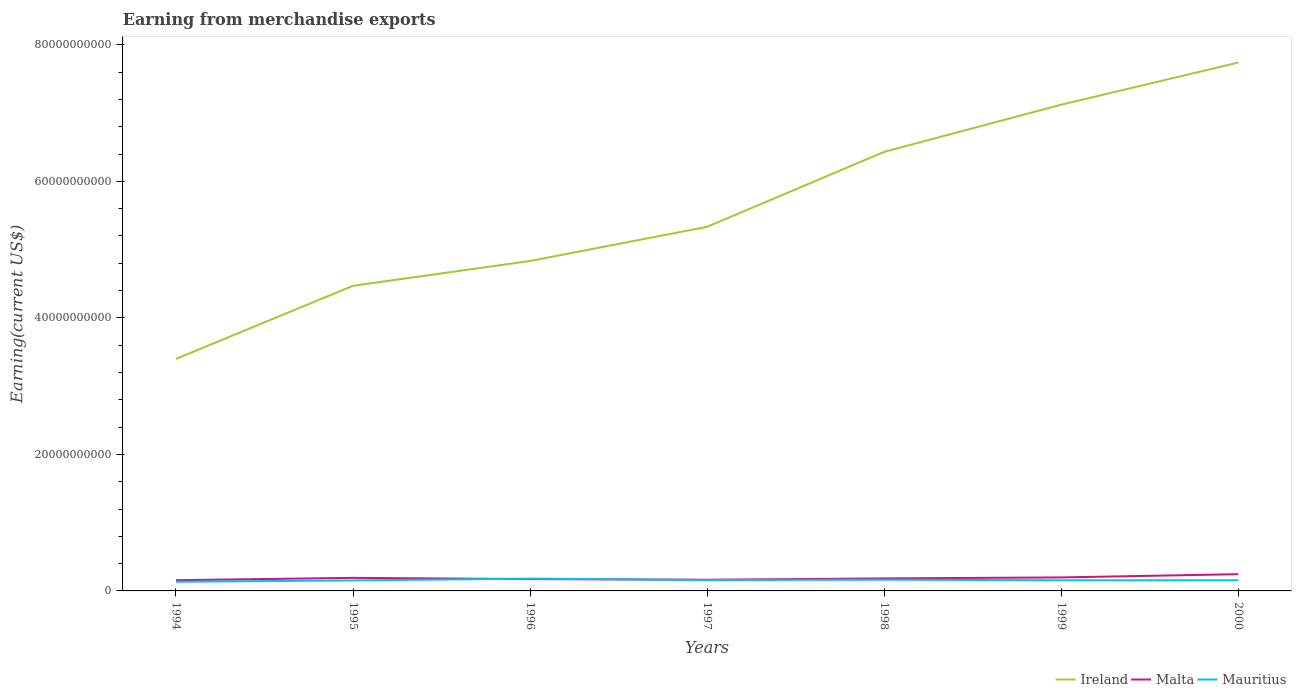How many different coloured lines are there?
Give a very brief answer. 3. Is the number of lines equal to the number of legend labels?
Keep it short and to the point. Yes. Across all years, what is the maximum amount earned from merchandise exports in Malta?
Your answer should be very brief. 1.57e+09. In which year was the amount earned from merchandise exports in Ireland maximum?
Ensure brevity in your answer.  1994. What is the total amount earned from merchandise exports in Malta in the graph?
Provide a short and direct response. -3.44e+08. What is the difference between the highest and the second highest amount earned from merchandise exports in Ireland?
Your answer should be very brief. 4.34e+1. How many years are there in the graph?
Your answer should be very brief. 7. Are the values on the major ticks of Y-axis written in scientific E-notation?
Provide a succinct answer. No. Does the graph contain grids?
Provide a succinct answer. No. How many legend labels are there?
Your answer should be compact. 3. What is the title of the graph?
Keep it short and to the point. Earning from merchandise exports. Does "Sao Tome and Principe" appear as one of the legend labels in the graph?
Provide a succinct answer. No. What is the label or title of the Y-axis?
Provide a succinct answer. Earning(current US$). What is the Earning(current US$) of Ireland in 1994?
Offer a terse response. 3.40e+1. What is the Earning(current US$) in Malta in 1994?
Your response must be concise. 1.57e+09. What is the Earning(current US$) in Mauritius in 1994?
Keep it short and to the point. 1.35e+09. What is the Earning(current US$) of Ireland in 1995?
Provide a short and direct response. 4.47e+1. What is the Earning(current US$) of Malta in 1995?
Give a very brief answer. 1.91e+09. What is the Earning(current US$) in Mauritius in 1995?
Give a very brief answer. 1.54e+09. What is the Earning(current US$) of Ireland in 1996?
Provide a short and direct response. 4.83e+1. What is the Earning(current US$) in Malta in 1996?
Ensure brevity in your answer.  1.73e+09. What is the Earning(current US$) in Mauritius in 1996?
Your answer should be very brief. 1.80e+09. What is the Earning(current US$) in Ireland in 1997?
Offer a terse response. 5.33e+1. What is the Earning(current US$) in Malta in 1997?
Keep it short and to the point. 1.64e+09. What is the Earning(current US$) of Mauritius in 1997?
Keep it short and to the point. 1.59e+09. What is the Earning(current US$) in Ireland in 1998?
Ensure brevity in your answer.  6.43e+1. What is the Earning(current US$) in Malta in 1998?
Your answer should be compact. 1.83e+09. What is the Earning(current US$) in Mauritius in 1998?
Your response must be concise. 1.64e+09. What is the Earning(current US$) in Ireland in 1999?
Ensure brevity in your answer.  7.12e+1. What is the Earning(current US$) of Malta in 1999?
Offer a very short reply. 1.98e+09. What is the Earning(current US$) of Mauritius in 1999?
Ensure brevity in your answer.  1.55e+09. What is the Earning(current US$) in Ireland in 2000?
Give a very brief answer. 7.74e+1. What is the Earning(current US$) in Malta in 2000?
Provide a short and direct response. 2.45e+09. What is the Earning(current US$) in Mauritius in 2000?
Ensure brevity in your answer.  1.56e+09. Across all years, what is the maximum Earning(current US$) in Ireland?
Your answer should be very brief. 7.74e+1. Across all years, what is the maximum Earning(current US$) of Malta?
Make the answer very short. 2.45e+09. Across all years, what is the maximum Earning(current US$) of Mauritius?
Provide a short and direct response. 1.80e+09. Across all years, what is the minimum Earning(current US$) in Ireland?
Make the answer very short. 3.40e+1. Across all years, what is the minimum Earning(current US$) in Malta?
Your answer should be very brief. 1.57e+09. Across all years, what is the minimum Earning(current US$) of Mauritius?
Offer a terse response. 1.35e+09. What is the total Earning(current US$) of Ireland in the graph?
Offer a very short reply. 3.93e+11. What is the total Earning(current US$) of Malta in the graph?
Make the answer very short. 1.31e+1. What is the total Earning(current US$) of Mauritius in the graph?
Give a very brief answer. 1.10e+1. What is the difference between the Earning(current US$) in Ireland in 1994 and that in 1995?
Make the answer very short. -1.07e+1. What is the difference between the Earning(current US$) of Malta in 1994 and that in 1995?
Provide a short and direct response. -3.44e+08. What is the difference between the Earning(current US$) of Mauritius in 1994 and that in 1995?
Offer a very short reply. -1.91e+08. What is the difference between the Earning(current US$) of Ireland in 1994 and that in 1996?
Ensure brevity in your answer.  -1.43e+1. What is the difference between the Earning(current US$) of Malta in 1994 and that in 1996?
Offer a very short reply. -1.61e+08. What is the difference between the Earning(current US$) of Mauritius in 1994 and that in 1996?
Offer a very short reply. -4.55e+08. What is the difference between the Earning(current US$) in Ireland in 1994 and that in 1997?
Your answer should be very brief. -1.94e+1. What is the difference between the Earning(current US$) in Malta in 1994 and that in 1997?
Provide a succinct answer. -7.10e+07. What is the difference between the Earning(current US$) in Mauritius in 1994 and that in 1997?
Offer a terse response. -2.45e+08. What is the difference between the Earning(current US$) in Ireland in 1994 and that in 1998?
Your answer should be compact. -3.03e+1. What is the difference between the Earning(current US$) in Malta in 1994 and that in 1998?
Make the answer very short. -2.64e+08. What is the difference between the Earning(current US$) in Mauritius in 1994 and that in 1998?
Ensure brevity in your answer.  -2.98e+08. What is the difference between the Earning(current US$) in Ireland in 1994 and that in 1999?
Ensure brevity in your answer.  -3.72e+1. What is the difference between the Earning(current US$) in Malta in 1994 and that in 1999?
Provide a succinct answer. -4.08e+08. What is the difference between the Earning(current US$) of Mauritius in 1994 and that in 1999?
Ensure brevity in your answer.  -2.07e+08. What is the difference between the Earning(current US$) in Ireland in 1994 and that in 2000?
Give a very brief answer. -4.34e+1. What is the difference between the Earning(current US$) in Malta in 1994 and that in 2000?
Make the answer very short. -8.83e+08. What is the difference between the Earning(current US$) of Mauritius in 1994 and that in 2000?
Your answer should be compact. -2.10e+08. What is the difference between the Earning(current US$) of Ireland in 1995 and that in 1996?
Give a very brief answer. -3.63e+09. What is the difference between the Earning(current US$) in Malta in 1995 and that in 1996?
Your response must be concise. 1.83e+08. What is the difference between the Earning(current US$) of Mauritius in 1995 and that in 1996?
Provide a short and direct response. -2.64e+08. What is the difference between the Earning(current US$) in Ireland in 1995 and that in 1997?
Give a very brief answer. -8.64e+09. What is the difference between the Earning(current US$) of Malta in 1995 and that in 1997?
Offer a terse response. 2.73e+08. What is the difference between the Earning(current US$) of Mauritius in 1995 and that in 1997?
Make the answer very short. -5.40e+07. What is the difference between the Earning(current US$) of Ireland in 1995 and that in 1998?
Provide a succinct answer. -1.96e+1. What is the difference between the Earning(current US$) of Malta in 1995 and that in 1998?
Offer a terse response. 8.00e+07. What is the difference between the Earning(current US$) of Mauritius in 1995 and that in 1998?
Ensure brevity in your answer.  -1.07e+08. What is the difference between the Earning(current US$) of Ireland in 1995 and that in 1999?
Give a very brief answer. -2.65e+1. What is the difference between the Earning(current US$) in Malta in 1995 and that in 1999?
Offer a terse response. -6.38e+07. What is the difference between the Earning(current US$) of Mauritius in 1995 and that in 1999?
Offer a very short reply. -1.60e+07. What is the difference between the Earning(current US$) of Ireland in 1995 and that in 2000?
Your answer should be compact. -3.27e+1. What is the difference between the Earning(current US$) of Malta in 1995 and that in 2000?
Your answer should be compact. -5.39e+08. What is the difference between the Earning(current US$) in Mauritius in 1995 and that in 2000?
Make the answer very short. -1.90e+07. What is the difference between the Earning(current US$) of Ireland in 1996 and that in 1997?
Provide a succinct answer. -5.01e+09. What is the difference between the Earning(current US$) of Malta in 1996 and that in 1997?
Provide a succinct answer. 9.00e+07. What is the difference between the Earning(current US$) in Mauritius in 1996 and that in 1997?
Give a very brief answer. 2.10e+08. What is the difference between the Earning(current US$) of Ireland in 1996 and that in 1998?
Give a very brief answer. -1.60e+1. What is the difference between the Earning(current US$) in Malta in 1996 and that in 1998?
Make the answer very short. -1.03e+08. What is the difference between the Earning(current US$) in Mauritius in 1996 and that in 1998?
Your answer should be compact. 1.57e+08. What is the difference between the Earning(current US$) in Ireland in 1996 and that in 1999?
Offer a very short reply. -2.29e+1. What is the difference between the Earning(current US$) of Malta in 1996 and that in 1999?
Give a very brief answer. -2.47e+08. What is the difference between the Earning(current US$) in Mauritius in 1996 and that in 1999?
Provide a succinct answer. 2.48e+08. What is the difference between the Earning(current US$) of Ireland in 1996 and that in 2000?
Your answer should be very brief. -2.91e+1. What is the difference between the Earning(current US$) in Malta in 1996 and that in 2000?
Offer a very short reply. -7.22e+08. What is the difference between the Earning(current US$) of Mauritius in 1996 and that in 2000?
Your response must be concise. 2.45e+08. What is the difference between the Earning(current US$) in Ireland in 1997 and that in 1998?
Ensure brevity in your answer.  -1.10e+1. What is the difference between the Earning(current US$) in Malta in 1997 and that in 1998?
Provide a short and direct response. -1.93e+08. What is the difference between the Earning(current US$) in Mauritius in 1997 and that in 1998?
Keep it short and to the point. -5.30e+07. What is the difference between the Earning(current US$) of Ireland in 1997 and that in 1999?
Offer a very short reply. -1.79e+1. What is the difference between the Earning(current US$) in Malta in 1997 and that in 1999?
Provide a short and direct response. -3.37e+08. What is the difference between the Earning(current US$) of Mauritius in 1997 and that in 1999?
Provide a short and direct response. 3.80e+07. What is the difference between the Earning(current US$) in Ireland in 1997 and that in 2000?
Make the answer very short. -2.41e+1. What is the difference between the Earning(current US$) in Malta in 1997 and that in 2000?
Your answer should be very brief. -8.12e+08. What is the difference between the Earning(current US$) of Mauritius in 1997 and that in 2000?
Ensure brevity in your answer.  3.50e+07. What is the difference between the Earning(current US$) in Ireland in 1998 and that in 1999?
Offer a terse response. -6.91e+09. What is the difference between the Earning(current US$) in Malta in 1998 and that in 1999?
Provide a succinct answer. -1.44e+08. What is the difference between the Earning(current US$) of Mauritius in 1998 and that in 1999?
Provide a succinct answer. 9.10e+07. What is the difference between the Earning(current US$) in Ireland in 1998 and that in 2000?
Your answer should be compact. -1.31e+1. What is the difference between the Earning(current US$) in Malta in 1998 and that in 2000?
Offer a terse response. -6.19e+08. What is the difference between the Earning(current US$) in Mauritius in 1998 and that in 2000?
Your answer should be very brief. 8.80e+07. What is the difference between the Earning(current US$) in Ireland in 1999 and that in 2000?
Offer a terse response. -6.17e+09. What is the difference between the Earning(current US$) in Malta in 1999 and that in 2000?
Offer a terse response. -4.75e+08. What is the difference between the Earning(current US$) in Mauritius in 1999 and that in 2000?
Your response must be concise. -3.00e+06. What is the difference between the Earning(current US$) of Ireland in 1994 and the Earning(current US$) of Malta in 1995?
Give a very brief answer. 3.21e+1. What is the difference between the Earning(current US$) of Ireland in 1994 and the Earning(current US$) of Mauritius in 1995?
Your answer should be compact. 3.25e+1. What is the difference between the Earning(current US$) of Malta in 1994 and the Earning(current US$) of Mauritius in 1995?
Your response must be concise. 3.20e+07. What is the difference between the Earning(current US$) in Ireland in 1994 and the Earning(current US$) in Malta in 1996?
Make the answer very short. 3.23e+1. What is the difference between the Earning(current US$) in Ireland in 1994 and the Earning(current US$) in Mauritius in 1996?
Provide a short and direct response. 3.22e+1. What is the difference between the Earning(current US$) in Malta in 1994 and the Earning(current US$) in Mauritius in 1996?
Your answer should be very brief. -2.32e+08. What is the difference between the Earning(current US$) in Ireland in 1994 and the Earning(current US$) in Malta in 1997?
Offer a very short reply. 3.24e+1. What is the difference between the Earning(current US$) of Ireland in 1994 and the Earning(current US$) of Mauritius in 1997?
Keep it short and to the point. 3.24e+1. What is the difference between the Earning(current US$) in Malta in 1994 and the Earning(current US$) in Mauritius in 1997?
Your answer should be very brief. -2.20e+07. What is the difference between the Earning(current US$) in Ireland in 1994 and the Earning(current US$) in Malta in 1998?
Provide a short and direct response. 3.22e+1. What is the difference between the Earning(current US$) in Ireland in 1994 and the Earning(current US$) in Mauritius in 1998?
Keep it short and to the point. 3.24e+1. What is the difference between the Earning(current US$) of Malta in 1994 and the Earning(current US$) of Mauritius in 1998?
Make the answer very short. -7.50e+07. What is the difference between the Earning(current US$) of Ireland in 1994 and the Earning(current US$) of Malta in 1999?
Keep it short and to the point. 3.20e+1. What is the difference between the Earning(current US$) of Ireland in 1994 and the Earning(current US$) of Mauritius in 1999?
Make the answer very short. 3.24e+1. What is the difference between the Earning(current US$) of Malta in 1994 and the Earning(current US$) of Mauritius in 1999?
Offer a terse response. 1.60e+07. What is the difference between the Earning(current US$) in Ireland in 1994 and the Earning(current US$) in Malta in 2000?
Offer a very short reply. 3.15e+1. What is the difference between the Earning(current US$) in Ireland in 1994 and the Earning(current US$) in Mauritius in 2000?
Your response must be concise. 3.24e+1. What is the difference between the Earning(current US$) of Malta in 1994 and the Earning(current US$) of Mauritius in 2000?
Ensure brevity in your answer.  1.30e+07. What is the difference between the Earning(current US$) of Ireland in 1995 and the Earning(current US$) of Malta in 1996?
Keep it short and to the point. 4.30e+1. What is the difference between the Earning(current US$) of Ireland in 1995 and the Earning(current US$) of Mauritius in 1996?
Make the answer very short. 4.29e+1. What is the difference between the Earning(current US$) of Malta in 1995 and the Earning(current US$) of Mauritius in 1996?
Provide a succinct answer. 1.12e+08. What is the difference between the Earning(current US$) in Ireland in 1995 and the Earning(current US$) in Malta in 1997?
Offer a very short reply. 4.31e+1. What is the difference between the Earning(current US$) in Ireland in 1995 and the Earning(current US$) in Mauritius in 1997?
Your answer should be compact. 4.31e+1. What is the difference between the Earning(current US$) of Malta in 1995 and the Earning(current US$) of Mauritius in 1997?
Ensure brevity in your answer.  3.22e+08. What is the difference between the Earning(current US$) of Ireland in 1995 and the Earning(current US$) of Malta in 1998?
Provide a short and direct response. 4.29e+1. What is the difference between the Earning(current US$) in Ireland in 1995 and the Earning(current US$) in Mauritius in 1998?
Offer a very short reply. 4.31e+1. What is the difference between the Earning(current US$) of Malta in 1995 and the Earning(current US$) of Mauritius in 1998?
Make the answer very short. 2.69e+08. What is the difference between the Earning(current US$) in Ireland in 1995 and the Earning(current US$) in Malta in 1999?
Provide a succinct answer. 4.27e+1. What is the difference between the Earning(current US$) of Ireland in 1995 and the Earning(current US$) of Mauritius in 1999?
Provide a succinct answer. 4.32e+1. What is the difference between the Earning(current US$) of Malta in 1995 and the Earning(current US$) of Mauritius in 1999?
Make the answer very short. 3.60e+08. What is the difference between the Earning(current US$) of Ireland in 1995 and the Earning(current US$) of Malta in 2000?
Make the answer very short. 4.23e+1. What is the difference between the Earning(current US$) of Ireland in 1995 and the Earning(current US$) of Mauritius in 2000?
Provide a succinct answer. 4.31e+1. What is the difference between the Earning(current US$) in Malta in 1995 and the Earning(current US$) in Mauritius in 2000?
Keep it short and to the point. 3.57e+08. What is the difference between the Earning(current US$) of Ireland in 1996 and the Earning(current US$) of Malta in 1997?
Give a very brief answer. 4.67e+1. What is the difference between the Earning(current US$) of Ireland in 1996 and the Earning(current US$) of Mauritius in 1997?
Keep it short and to the point. 4.67e+1. What is the difference between the Earning(current US$) in Malta in 1996 and the Earning(current US$) in Mauritius in 1997?
Your response must be concise. 1.39e+08. What is the difference between the Earning(current US$) in Ireland in 1996 and the Earning(current US$) in Malta in 1998?
Make the answer very short. 4.65e+1. What is the difference between the Earning(current US$) of Ireland in 1996 and the Earning(current US$) of Mauritius in 1998?
Your response must be concise. 4.67e+1. What is the difference between the Earning(current US$) in Malta in 1996 and the Earning(current US$) in Mauritius in 1998?
Your answer should be very brief. 8.60e+07. What is the difference between the Earning(current US$) in Ireland in 1996 and the Earning(current US$) in Malta in 1999?
Your response must be concise. 4.64e+1. What is the difference between the Earning(current US$) of Ireland in 1996 and the Earning(current US$) of Mauritius in 1999?
Provide a short and direct response. 4.68e+1. What is the difference between the Earning(current US$) in Malta in 1996 and the Earning(current US$) in Mauritius in 1999?
Provide a succinct answer. 1.77e+08. What is the difference between the Earning(current US$) in Ireland in 1996 and the Earning(current US$) in Malta in 2000?
Provide a succinct answer. 4.59e+1. What is the difference between the Earning(current US$) of Ireland in 1996 and the Earning(current US$) of Mauritius in 2000?
Give a very brief answer. 4.68e+1. What is the difference between the Earning(current US$) in Malta in 1996 and the Earning(current US$) in Mauritius in 2000?
Provide a succinct answer. 1.74e+08. What is the difference between the Earning(current US$) in Ireland in 1997 and the Earning(current US$) in Malta in 1998?
Your response must be concise. 5.15e+1. What is the difference between the Earning(current US$) of Ireland in 1997 and the Earning(current US$) of Mauritius in 1998?
Provide a short and direct response. 5.17e+1. What is the difference between the Earning(current US$) in Malta in 1997 and the Earning(current US$) in Mauritius in 1998?
Offer a very short reply. -4.00e+06. What is the difference between the Earning(current US$) of Ireland in 1997 and the Earning(current US$) of Malta in 1999?
Provide a succinct answer. 5.14e+1. What is the difference between the Earning(current US$) of Ireland in 1997 and the Earning(current US$) of Mauritius in 1999?
Offer a very short reply. 5.18e+1. What is the difference between the Earning(current US$) of Malta in 1997 and the Earning(current US$) of Mauritius in 1999?
Make the answer very short. 8.70e+07. What is the difference between the Earning(current US$) of Ireland in 1997 and the Earning(current US$) of Malta in 2000?
Your answer should be very brief. 5.09e+1. What is the difference between the Earning(current US$) of Ireland in 1997 and the Earning(current US$) of Mauritius in 2000?
Your answer should be compact. 5.18e+1. What is the difference between the Earning(current US$) in Malta in 1997 and the Earning(current US$) in Mauritius in 2000?
Offer a terse response. 8.40e+07. What is the difference between the Earning(current US$) in Ireland in 1998 and the Earning(current US$) in Malta in 1999?
Give a very brief answer. 6.24e+1. What is the difference between the Earning(current US$) of Ireland in 1998 and the Earning(current US$) of Mauritius in 1999?
Your answer should be compact. 6.28e+1. What is the difference between the Earning(current US$) in Malta in 1998 and the Earning(current US$) in Mauritius in 1999?
Provide a short and direct response. 2.80e+08. What is the difference between the Earning(current US$) in Ireland in 1998 and the Earning(current US$) in Malta in 2000?
Provide a succinct answer. 6.19e+1. What is the difference between the Earning(current US$) of Ireland in 1998 and the Earning(current US$) of Mauritius in 2000?
Your response must be concise. 6.28e+1. What is the difference between the Earning(current US$) in Malta in 1998 and the Earning(current US$) in Mauritius in 2000?
Make the answer very short. 2.77e+08. What is the difference between the Earning(current US$) of Ireland in 1999 and the Earning(current US$) of Malta in 2000?
Provide a short and direct response. 6.88e+1. What is the difference between the Earning(current US$) in Ireland in 1999 and the Earning(current US$) in Mauritius in 2000?
Keep it short and to the point. 6.97e+1. What is the difference between the Earning(current US$) in Malta in 1999 and the Earning(current US$) in Mauritius in 2000?
Your response must be concise. 4.21e+08. What is the average Earning(current US$) of Ireland per year?
Provide a short and direct response. 5.62e+1. What is the average Earning(current US$) of Malta per year?
Keep it short and to the point. 1.87e+09. What is the average Earning(current US$) of Mauritius per year?
Offer a very short reply. 1.58e+09. In the year 1994, what is the difference between the Earning(current US$) in Ireland and Earning(current US$) in Malta?
Offer a terse response. 3.24e+1. In the year 1994, what is the difference between the Earning(current US$) in Ireland and Earning(current US$) in Mauritius?
Provide a succinct answer. 3.26e+1. In the year 1994, what is the difference between the Earning(current US$) in Malta and Earning(current US$) in Mauritius?
Your answer should be very brief. 2.23e+08. In the year 1995, what is the difference between the Earning(current US$) in Ireland and Earning(current US$) in Malta?
Offer a very short reply. 4.28e+1. In the year 1995, what is the difference between the Earning(current US$) of Ireland and Earning(current US$) of Mauritius?
Keep it short and to the point. 4.32e+1. In the year 1995, what is the difference between the Earning(current US$) in Malta and Earning(current US$) in Mauritius?
Provide a succinct answer. 3.76e+08. In the year 1996, what is the difference between the Earning(current US$) in Ireland and Earning(current US$) in Malta?
Ensure brevity in your answer.  4.66e+1. In the year 1996, what is the difference between the Earning(current US$) in Ireland and Earning(current US$) in Mauritius?
Offer a terse response. 4.65e+1. In the year 1996, what is the difference between the Earning(current US$) in Malta and Earning(current US$) in Mauritius?
Keep it short and to the point. -7.10e+07. In the year 1997, what is the difference between the Earning(current US$) of Ireland and Earning(current US$) of Malta?
Keep it short and to the point. 5.17e+1. In the year 1997, what is the difference between the Earning(current US$) in Ireland and Earning(current US$) in Mauritius?
Ensure brevity in your answer.  5.18e+1. In the year 1997, what is the difference between the Earning(current US$) in Malta and Earning(current US$) in Mauritius?
Offer a terse response. 4.90e+07. In the year 1998, what is the difference between the Earning(current US$) of Ireland and Earning(current US$) of Malta?
Your response must be concise. 6.25e+1. In the year 1998, what is the difference between the Earning(current US$) of Ireland and Earning(current US$) of Mauritius?
Ensure brevity in your answer.  6.27e+1. In the year 1998, what is the difference between the Earning(current US$) of Malta and Earning(current US$) of Mauritius?
Provide a short and direct response. 1.89e+08. In the year 1999, what is the difference between the Earning(current US$) in Ireland and Earning(current US$) in Malta?
Your response must be concise. 6.93e+1. In the year 1999, what is the difference between the Earning(current US$) in Ireland and Earning(current US$) in Mauritius?
Offer a terse response. 6.97e+1. In the year 1999, what is the difference between the Earning(current US$) in Malta and Earning(current US$) in Mauritius?
Give a very brief answer. 4.24e+08. In the year 2000, what is the difference between the Earning(current US$) in Ireland and Earning(current US$) in Malta?
Provide a short and direct response. 7.50e+1. In the year 2000, what is the difference between the Earning(current US$) in Ireland and Earning(current US$) in Mauritius?
Your response must be concise. 7.59e+1. In the year 2000, what is the difference between the Earning(current US$) in Malta and Earning(current US$) in Mauritius?
Give a very brief answer. 8.96e+08. What is the ratio of the Earning(current US$) in Ireland in 1994 to that in 1995?
Offer a terse response. 0.76. What is the ratio of the Earning(current US$) in Malta in 1994 to that in 1995?
Make the answer very short. 0.82. What is the ratio of the Earning(current US$) in Mauritius in 1994 to that in 1995?
Your answer should be very brief. 0.88. What is the ratio of the Earning(current US$) in Ireland in 1994 to that in 1996?
Offer a very short reply. 0.7. What is the ratio of the Earning(current US$) of Malta in 1994 to that in 1996?
Your answer should be compact. 0.91. What is the ratio of the Earning(current US$) of Mauritius in 1994 to that in 1996?
Give a very brief answer. 0.75. What is the ratio of the Earning(current US$) in Ireland in 1994 to that in 1997?
Offer a very short reply. 0.64. What is the ratio of the Earning(current US$) in Malta in 1994 to that in 1997?
Your response must be concise. 0.96. What is the ratio of the Earning(current US$) in Mauritius in 1994 to that in 1997?
Your answer should be very brief. 0.85. What is the ratio of the Earning(current US$) in Ireland in 1994 to that in 1998?
Provide a succinct answer. 0.53. What is the ratio of the Earning(current US$) in Malta in 1994 to that in 1998?
Offer a terse response. 0.86. What is the ratio of the Earning(current US$) of Mauritius in 1994 to that in 1998?
Offer a terse response. 0.82. What is the ratio of the Earning(current US$) in Ireland in 1994 to that in 1999?
Your answer should be compact. 0.48. What is the ratio of the Earning(current US$) in Malta in 1994 to that in 1999?
Give a very brief answer. 0.79. What is the ratio of the Earning(current US$) in Mauritius in 1994 to that in 1999?
Ensure brevity in your answer.  0.87. What is the ratio of the Earning(current US$) in Ireland in 1994 to that in 2000?
Ensure brevity in your answer.  0.44. What is the ratio of the Earning(current US$) of Malta in 1994 to that in 2000?
Offer a very short reply. 0.64. What is the ratio of the Earning(current US$) of Mauritius in 1994 to that in 2000?
Offer a terse response. 0.87. What is the ratio of the Earning(current US$) in Ireland in 1995 to that in 1996?
Provide a succinct answer. 0.92. What is the ratio of the Earning(current US$) in Malta in 1995 to that in 1996?
Provide a succinct answer. 1.11. What is the ratio of the Earning(current US$) in Mauritius in 1995 to that in 1996?
Provide a succinct answer. 0.85. What is the ratio of the Earning(current US$) in Ireland in 1995 to that in 1997?
Make the answer very short. 0.84. What is the ratio of the Earning(current US$) in Malta in 1995 to that in 1997?
Provide a succinct answer. 1.17. What is the ratio of the Earning(current US$) of Mauritius in 1995 to that in 1997?
Your answer should be very brief. 0.97. What is the ratio of the Earning(current US$) of Ireland in 1995 to that in 1998?
Ensure brevity in your answer.  0.69. What is the ratio of the Earning(current US$) in Malta in 1995 to that in 1998?
Your response must be concise. 1.04. What is the ratio of the Earning(current US$) in Mauritius in 1995 to that in 1998?
Make the answer very short. 0.94. What is the ratio of the Earning(current US$) in Ireland in 1995 to that in 1999?
Provide a succinct answer. 0.63. What is the ratio of the Earning(current US$) of Malta in 1995 to that in 1999?
Your answer should be compact. 0.97. What is the ratio of the Earning(current US$) of Mauritius in 1995 to that in 1999?
Ensure brevity in your answer.  0.99. What is the ratio of the Earning(current US$) in Ireland in 1995 to that in 2000?
Ensure brevity in your answer.  0.58. What is the ratio of the Earning(current US$) in Malta in 1995 to that in 2000?
Your response must be concise. 0.78. What is the ratio of the Earning(current US$) of Mauritius in 1995 to that in 2000?
Ensure brevity in your answer.  0.99. What is the ratio of the Earning(current US$) of Ireland in 1996 to that in 1997?
Keep it short and to the point. 0.91. What is the ratio of the Earning(current US$) of Malta in 1996 to that in 1997?
Your answer should be very brief. 1.05. What is the ratio of the Earning(current US$) of Mauritius in 1996 to that in 1997?
Give a very brief answer. 1.13. What is the ratio of the Earning(current US$) in Ireland in 1996 to that in 1998?
Keep it short and to the point. 0.75. What is the ratio of the Earning(current US$) of Malta in 1996 to that in 1998?
Offer a terse response. 0.94. What is the ratio of the Earning(current US$) in Mauritius in 1996 to that in 1998?
Your answer should be very brief. 1.1. What is the ratio of the Earning(current US$) of Ireland in 1996 to that in 1999?
Make the answer very short. 0.68. What is the ratio of the Earning(current US$) of Malta in 1996 to that in 1999?
Provide a short and direct response. 0.88. What is the ratio of the Earning(current US$) of Mauritius in 1996 to that in 1999?
Provide a succinct answer. 1.16. What is the ratio of the Earning(current US$) in Ireland in 1996 to that in 2000?
Ensure brevity in your answer.  0.62. What is the ratio of the Earning(current US$) in Malta in 1996 to that in 2000?
Offer a very short reply. 0.71. What is the ratio of the Earning(current US$) in Mauritius in 1996 to that in 2000?
Provide a short and direct response. 1.16. What is the ratio of the Earning(current US$) in Ireland in 1997 to that in 1998?
Provide a succinct answer. 0.83. What is the ratio of the Earning(current US$) of Malta in 1997 to that in 1998?
Ensure brevity in your answer.  0.89. What is the ratio of the Earning(current US$) in Mauritius in 1997 to that in 1998?
Your response must be concise. 0.97. What is the ratio of the Earning(current US$) in Ireland in 1997 to that in 1999?
Provide a succinct answer. 0.75. What is the ratio of the Earning(current US$) in Malta in 1997 to that in 1999?
Make the answer very short. 0.83. What is the ratio of the Earning(current US$) of Mauritius in 1997 to that in 1999?
Give a very brief answer. 1.02. What is the ratio of the Earning(current US$) of Ireland in 1997 to that in 2000?
Offer a terse response. 0.69. What is the ratio of the Earning(current US$) of Malta in 1997 to that in 2000?
Offer a very short reply. 0.67. What is the ratio of the Earning(current US$) of Mauritius in 1997 to that in 2000?
Your answer should be compact. 1.02. What is the ratio of the Earning(current US$) of Ireland in 1998 to that in 1999?
Your answer should be very brief. 0.9. What is the ratio of the Earning(current US$) of Malta in 1998 to that in 1999?
Your response must be concise. 0.93. What is the ratio of the Earning(current US$) of Mauritius in 1998 to that in 1999?
Keep it short and to the point. 1.06. What is the ratio of the Earning(current US$) of Ireland in 1998 to that in 2000?
Offer a terse response. 0.83. What is the ratio of the Earning(current US$) in Malta in 1998 to that in 2000?
Make the answer very short. 0.75. What is the ratio of the Earning(current US$) in Mauritius in 1998 to that in 2000?
Provide a short and direct response. 1.06. What is the ratio of the Earning(current US$) in Ireland in 1999 to that in 2000?
Your response must be concise. 0.92. What is the ratio of the Earning(current US$) of Malta in 1999 to that in 2000?
Your answer should be very brief. 0.81. What is the difference between the highest and the second highest Earning(current US$) of Ireland?
Make the answer very short. 6.17e+09. What is the difference between the highest and the second highest Earning(current US$) of Malta?
Provide a short and direct response. 4.75e+08. What is the difference between the highest and the second highest Earning(current US$) in Mauritius?
Give a very brief answer. 1.57e+08. What is the difference between the highest and the lowest Earning(current US$) of Ireland?
Ensure brevity in your answer.  4.34e+1. What is the difference between the highest and the lowest Earning(current US$) of Malta?
Provide a short and direct response. 8.83e+08. What is the difference between the highest and the lowest Earning(current US$) of Mauritius?
Give a very brief answer. 4.55e+08. 